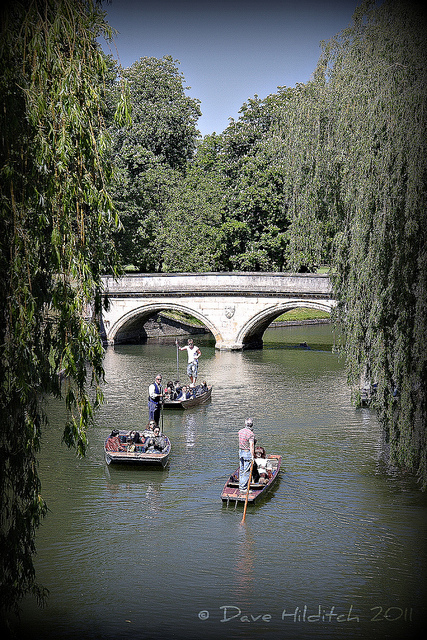Please extract the text content from this image. Dave 2011 C 